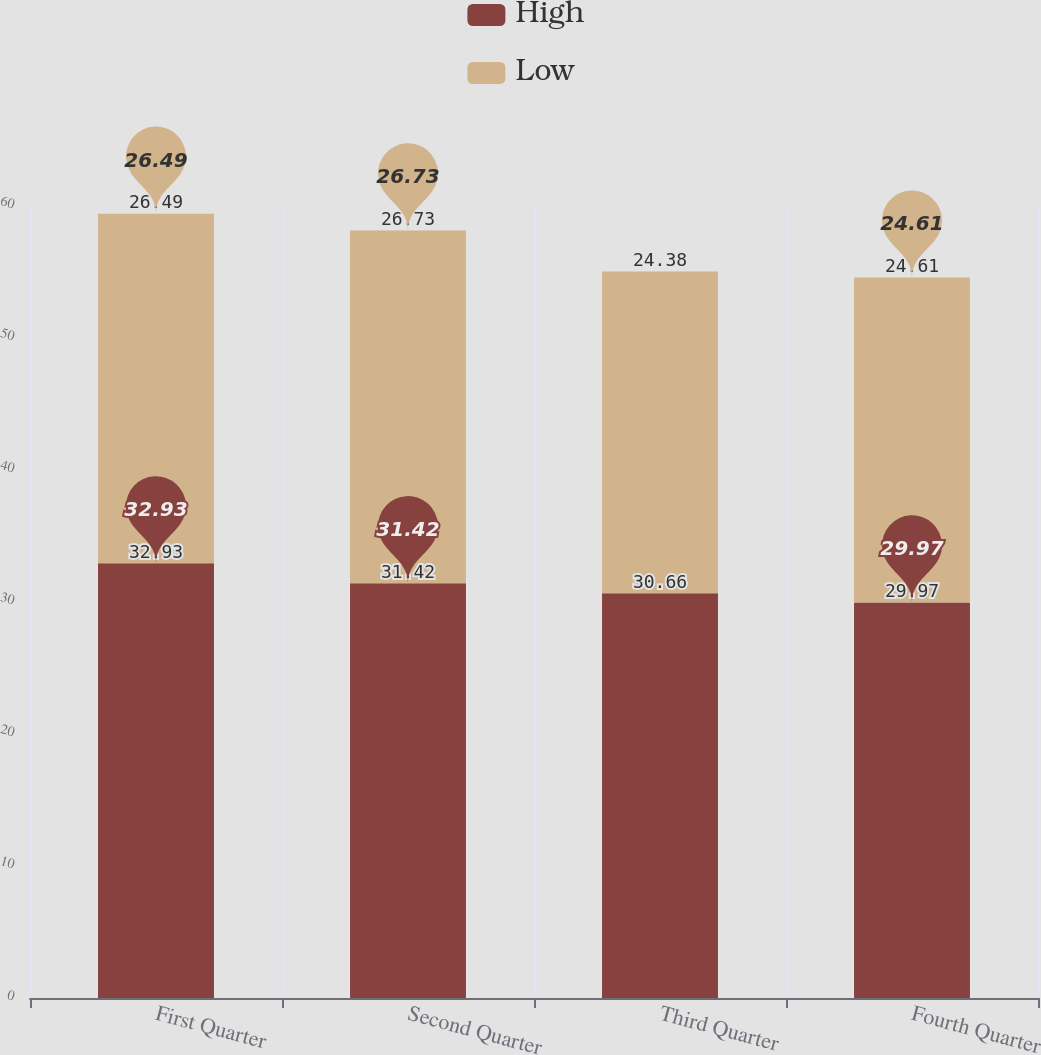Convert chart to OTSL. <chart><loc_0><loc_0><loc_500><loc_500><stacked_bar_chart><ecel><fcel>First Quarter<fcel>Second Quarter<fcel>Third Quarter<fcel>Fourth Quarter<nl><fcel>High<fcel>32.93<fcel>31.42<fcel>30.66<fcel>29.97<nl><fcel>Low<fcel>26.49<fcel>26.73<fcel>24.38<fcel>24.61<nl></chart> 